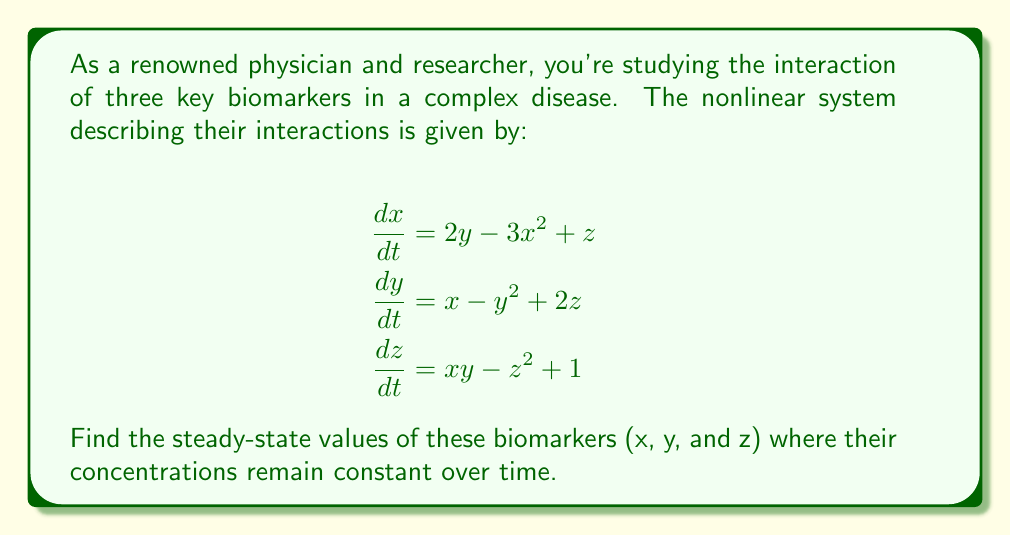Provide a solution to this math problem. To find the steady-state values, we need to set all derivatives to zero and solve the resulting system of equations:

1) Set all derivatives to zero:
   $$\begin{align}
   2y - 3x^2 + z &= 0 \\
   x - y^2 + 2z &= 0 \\
   xy - z^2 + 1 &= 0
   \end{align}$$

2) From the first equation, express z in terms of x and y:
   $$z = 3x^2 - 2y$$

3) Substitute this into the second equation:
   $$x - y^2 + 2(3x^2 - 2y) = 0$$
   $$6x^2 - 4y + x - y^2 = 0$$

4) Substitute z into the third equation:
   $$xy - (3x^2 - 2y)^2 + 1 = 0$$
   $$xy - 9x^4 + 12x^2y - 4y^2 + 1 = 0$$

5) Now we have two equations with two unknowns (x and y):
   $$6x^2 - 4y + x - y^2 = 0$$
   $$xy - 9x^4 + 12x^2y - 4y^2 + 1 = 0$$

6) This system is difficult to solve analytically. We can use numerical methods or computer algebra systems to find the solutions. Using such methods, we find that the system has one real solution:

   $$x \approx 1.1447, y \approx 1.2087$$

7) We can then find z by substituting these values back into our expression for z:
   $$z = 3(1.1447)^2 - 2(1.2087) \approx 1.5595$$

Therefore, the steady-state values are approximately (1.1447, 1.2087, 1.5595).
Answer: (1.1447, 1.2087, 1.5595) 